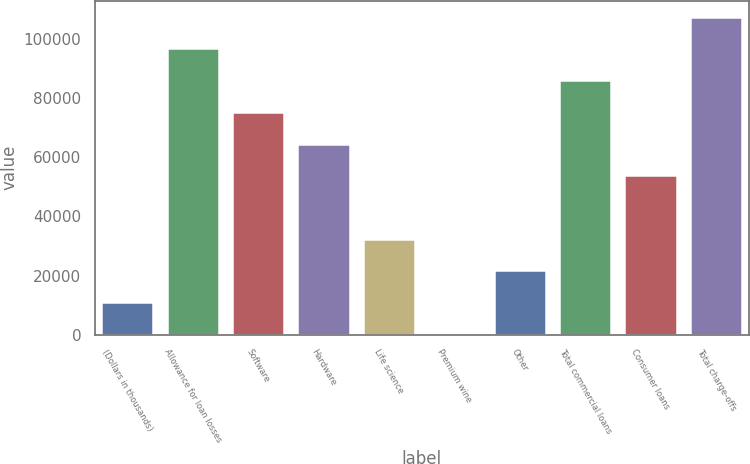Convert chart. <chart><loc_0><loc_0><loc_500><loc_500><bar_chart><fcel>(Dollars in thousands)<fcel>Allowance for loan losses<fcel>Software<fcel>Hardware<fcel>Life science<fcel>Premium wine<fcel>Other<fcel>Total commercial loans<fcel>Consumer loans<fcel>Total charge-offs<nl><fcel>11017.7<fcel>96687.3<fcel>75269.9<fcel>64561.2<fcel>32435.1<fcel>309<fcel>21726.4<fcel>85978.6<fcel>53852.5<fcel>107396<nl></chart> 